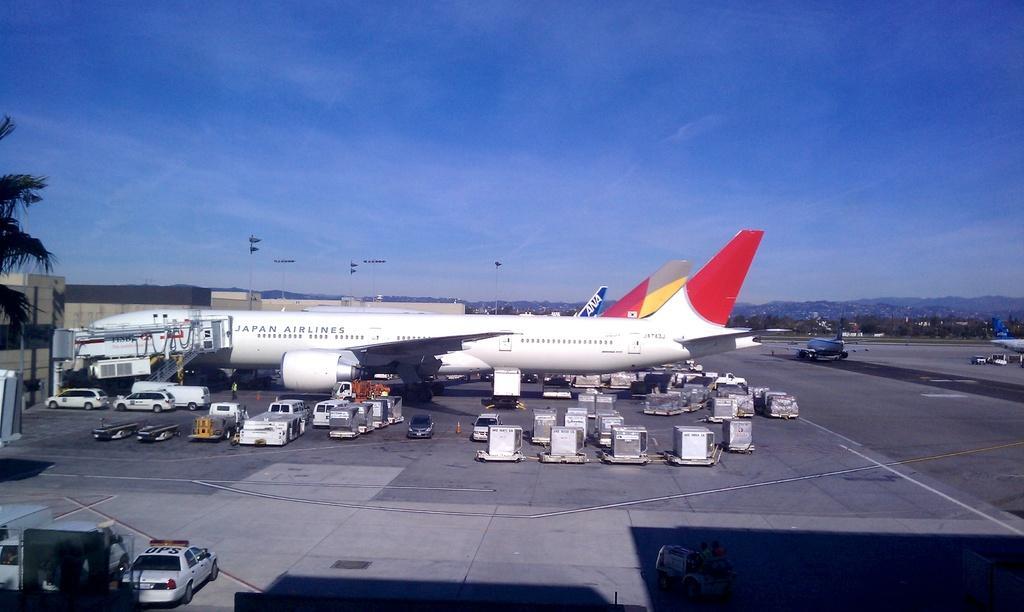In one or two sentences, can you explain what this image depicts? In this image in the center there are cars and there are containers on the road and there is an Airplane with some text written on it. In the background there are flags, there are trees and the sky is cloudy. On the right side there is a building and there is a tree. 